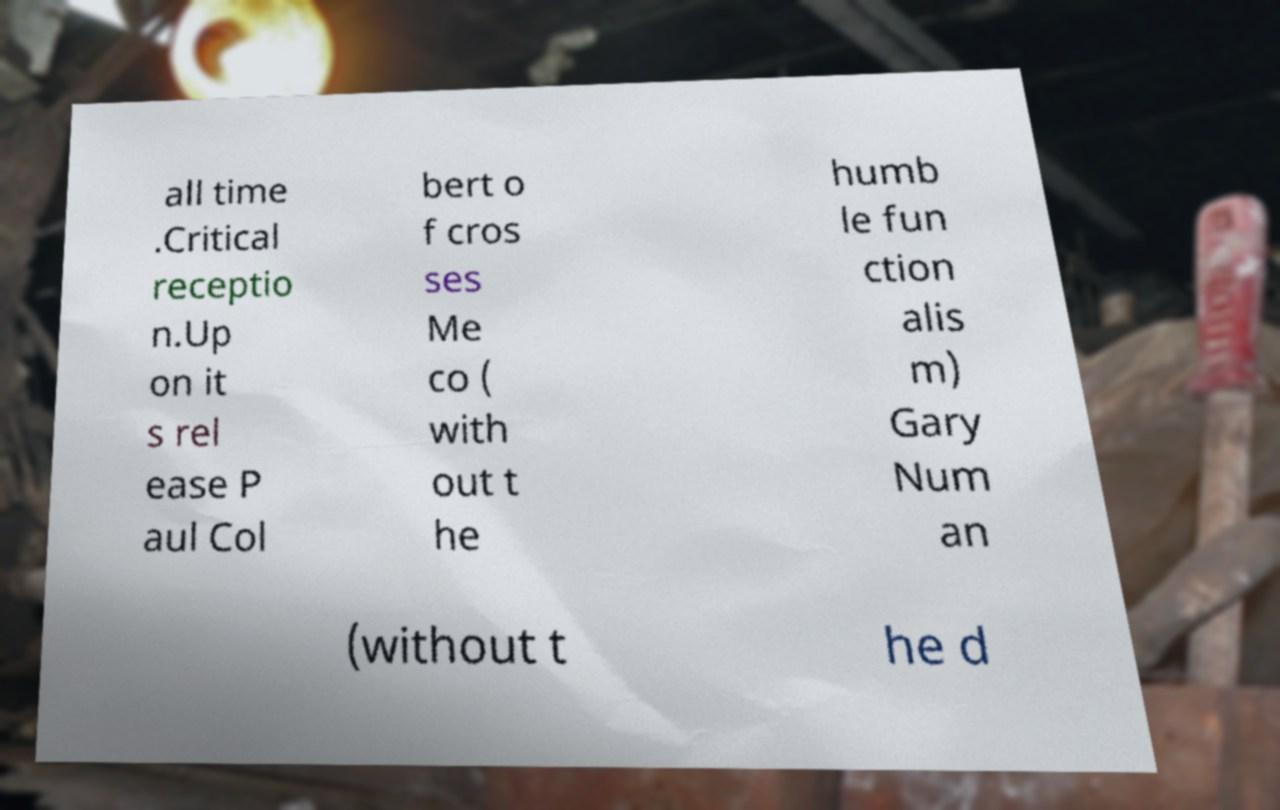Could you assist in decoding the text presented in this image and type it out clearly? all time .Critical receptio n.Up on it s rel ease P aul Col bert o f cros ses Me co ( with out t he humb le fun ction alis m) Gary Num an (without t he d 